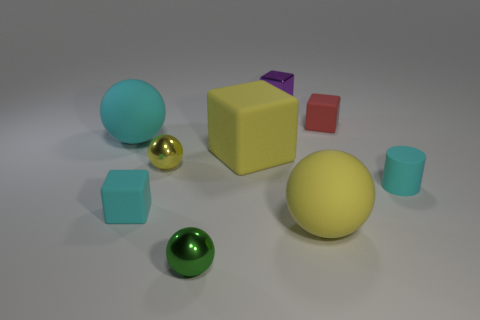Add 1 tiny metallic spheres. How many objects exist? 10 Subtract all balls. How many objects are left? 5 Add 3 small cyan things. How many small cyan things are left? 5 Add 6 tiny green metal things. How many tiny green metal things exist? 7 Subtract 0 purple balls. How many objects are left? 9 Subtract all matte cubes. Subtract all tiny red rubber blocks. How many objects are left? 5 